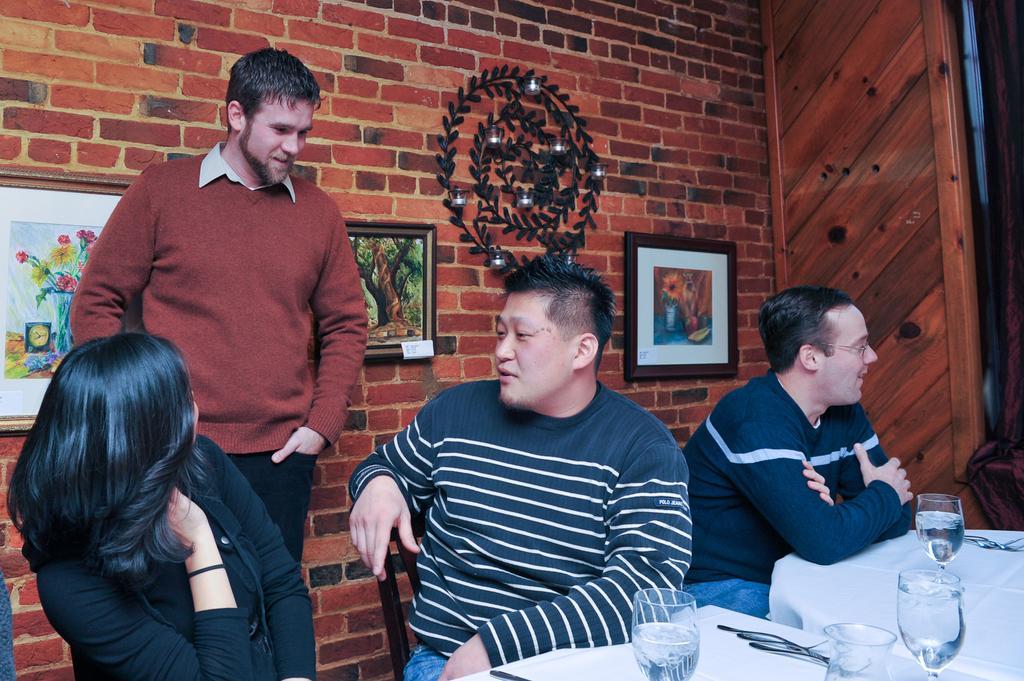Describe this image in one or two sentences. There are four people in a room. The three persons are sitting on a chairs. On the left side we have a one person is standing. There is a table. There is a glass,fork on a table. We can see in background photo frame,red wall brick ,cupboard. 